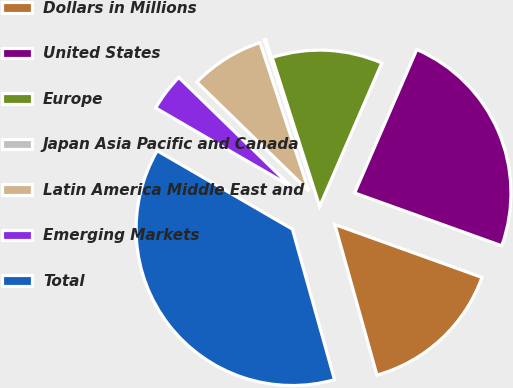Convert chart. <chart><loc_0><loc_0><loc_500><loc_500><pie_chart><fcel>Dollars in Millions<fcel>United States<fcel>Europe<fcel>Japan Asia Pacific and Canada<fcel>Latin America Middle East and<fcel>Emerging Markets<fcel>Total<nl><fcel>15.17%<fcel>23.98%<fcel>11.42%<fcel>0.15%<fcel>7.66%<fcel>3.91%<fcel>37.71%<nl></chart> 